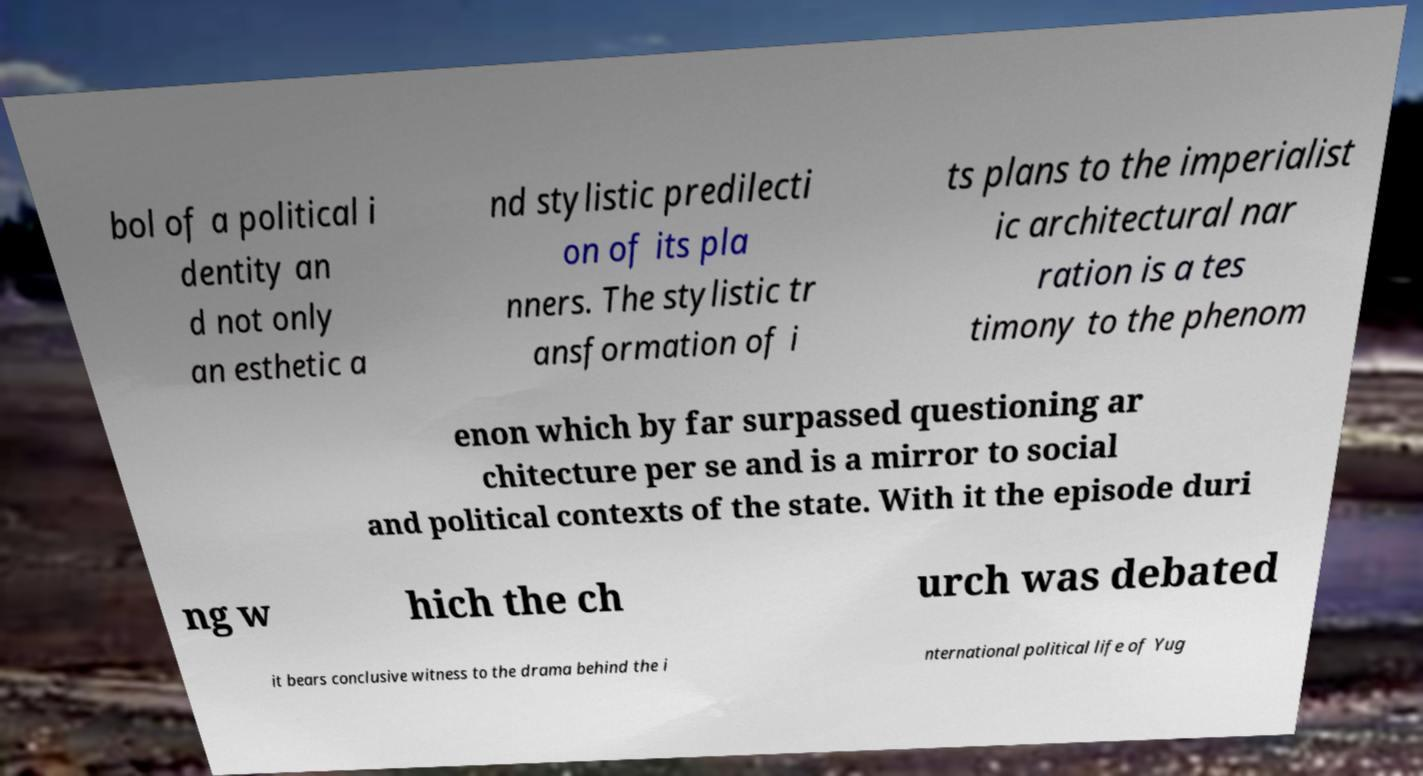Could you extract and type out the text from this image? bol of a political i dentity an d not only an esthetic a nd stylistic predilecti on of its pla nners. The stylistic tr ansformation of i ts plans to the imperialist ic architectural nar ration is a tes timony to the phenom enon which by far surpassed questioning ar chitecture per se and is a mirror to social and political contexts of the state. With it the episode duri ng w hich the ch urch was debated it bears conclusive witness to the drama behind the i nternational political life of Yug 